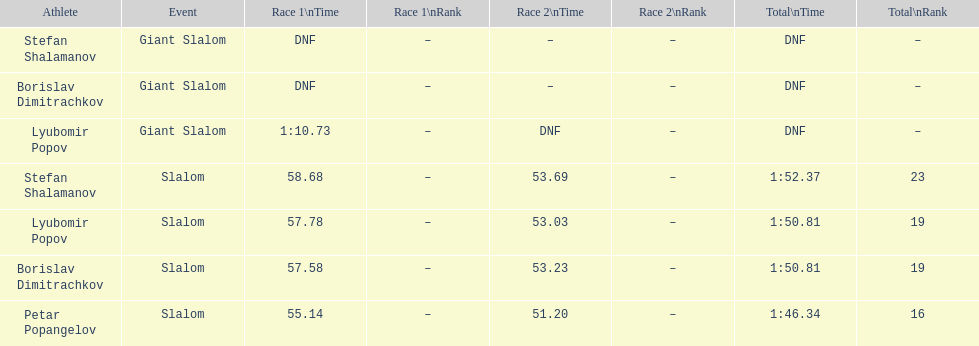Who was the other athlete who tied in rank with lyubomir popov? Borislav Dimitrachkov. 